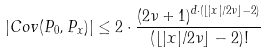<formula> <loc_0><loc_0><loc_500><loc_500>\left | C o v ( P _ { 0 } , P _ { x } ) \right | \leq 2 \cdot \frac { ( 2 \nu + 1 ) ^ { d \cdot ( \lfloor | x | / 2 \nu \rfloor - 2 ) } } { ( \lfloor | x | / 2 \nu \rfloor - 2 ) ! }</formula> 